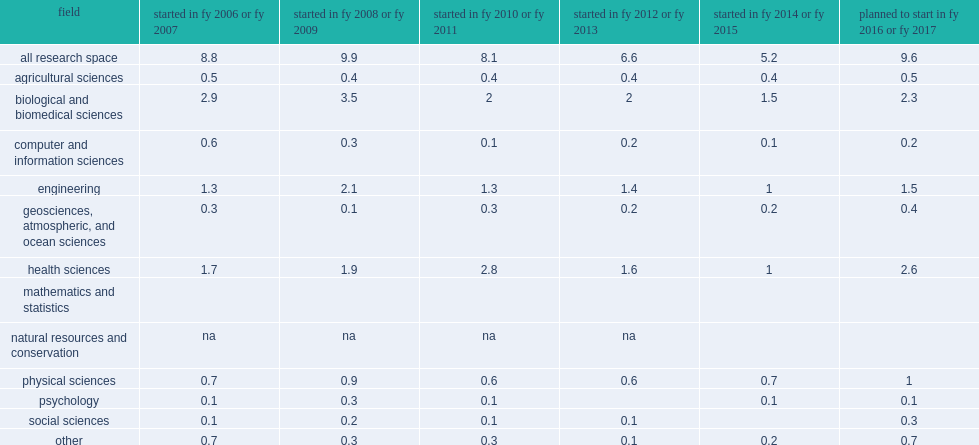How many million nasf was construction projects for biological and biomedical sciences? 1.5. How many million nasf was construction projects for engineering? 1.0. How many million nasf was construction projects for health sciences? 1.0. How many million nasf of planned new research space construction anticipated to begin in fy 2016 or fy 2017? 9.6. How many million nasf was planned for fys 2010 and 2011? 8.1. 